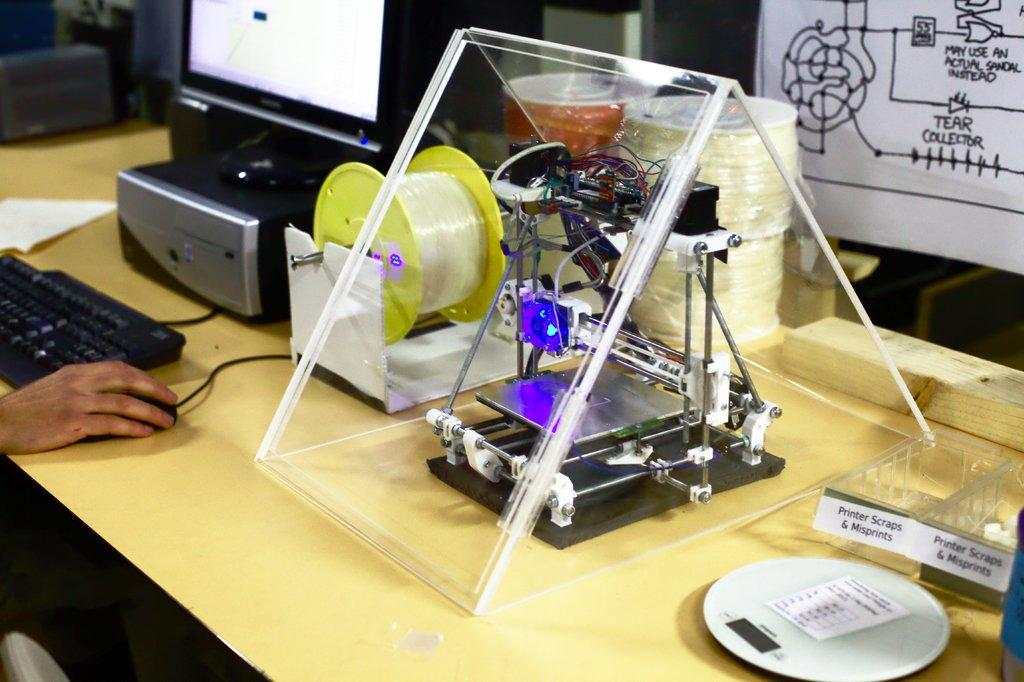What is the person's hand doing in the image? The person's hand is on a mouse in the image. What other device is present in the image? There is a keyboard in the image. What type of items can be seen on the table in the image? There are papers and other objects on the table in the image. Can you describe the background of the image? There are objects visible in the background of the image. What type of vegetable is being used as a smile in the image? There is no vegetable or smile present in the image; it features a person's hand on a mouse and a keyboard. 